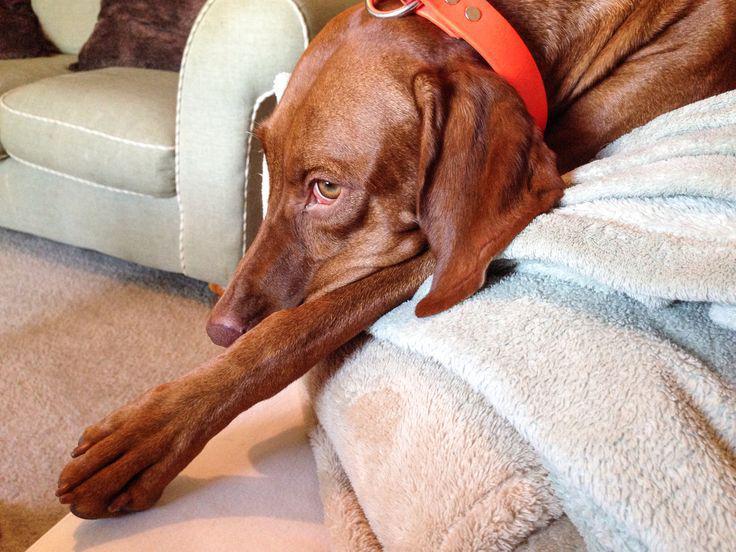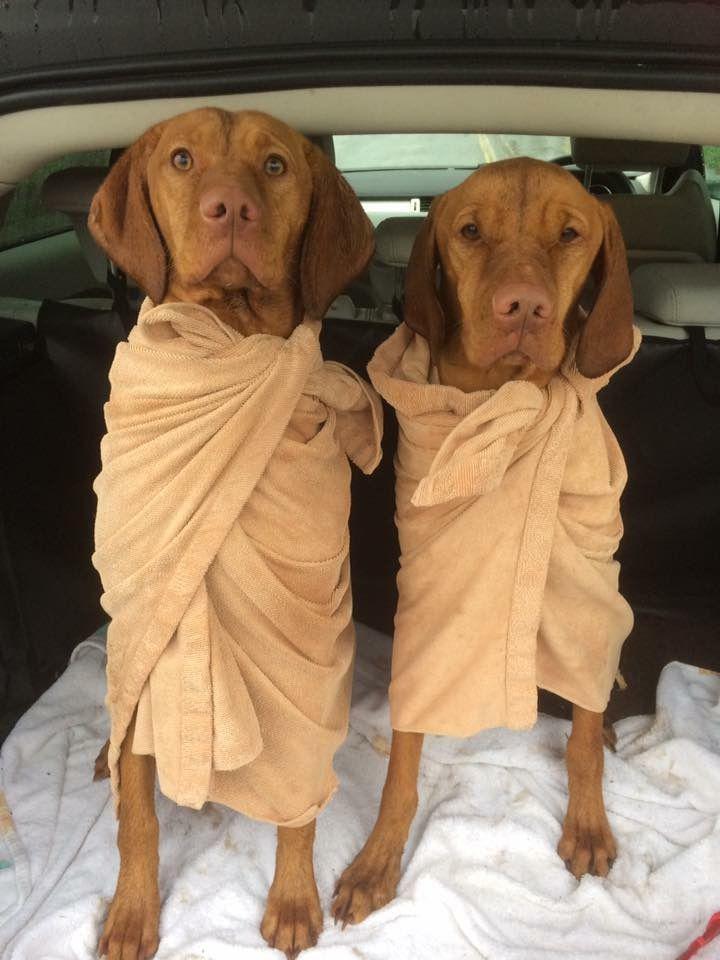The first image is the image on the left, the second image is the image on the right. Considering the images on both sides, is "The left image includes at least one extended paw in the foreground, and a collar worn by a reclining dog." valid? Answer yes or no. Yes. 